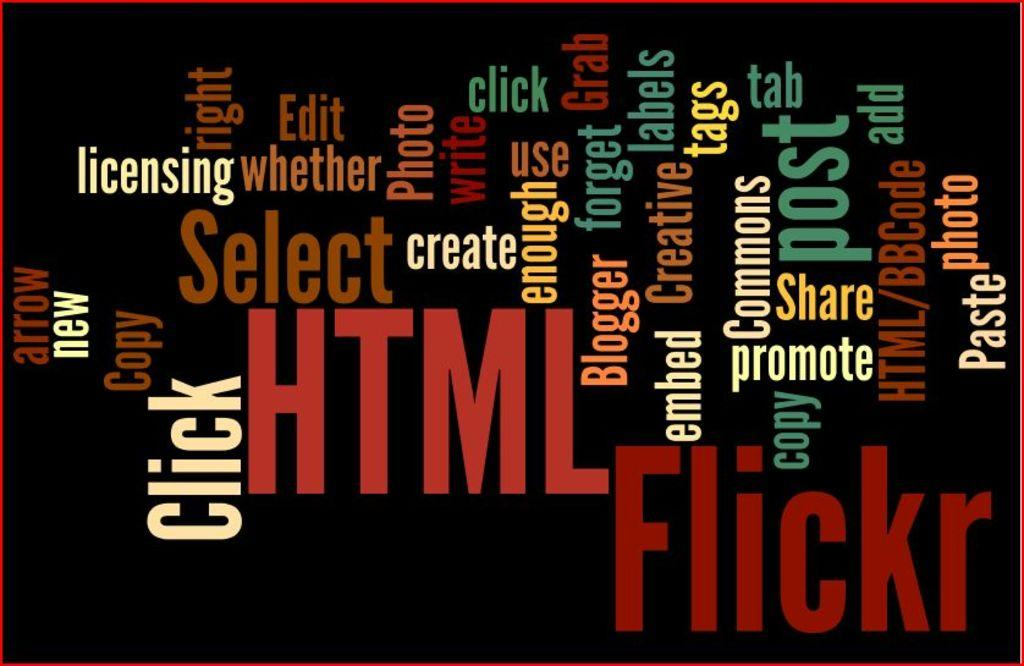<image>
Share a concise interpretation of the image provided. A word soup featuring words like click and flickr. 